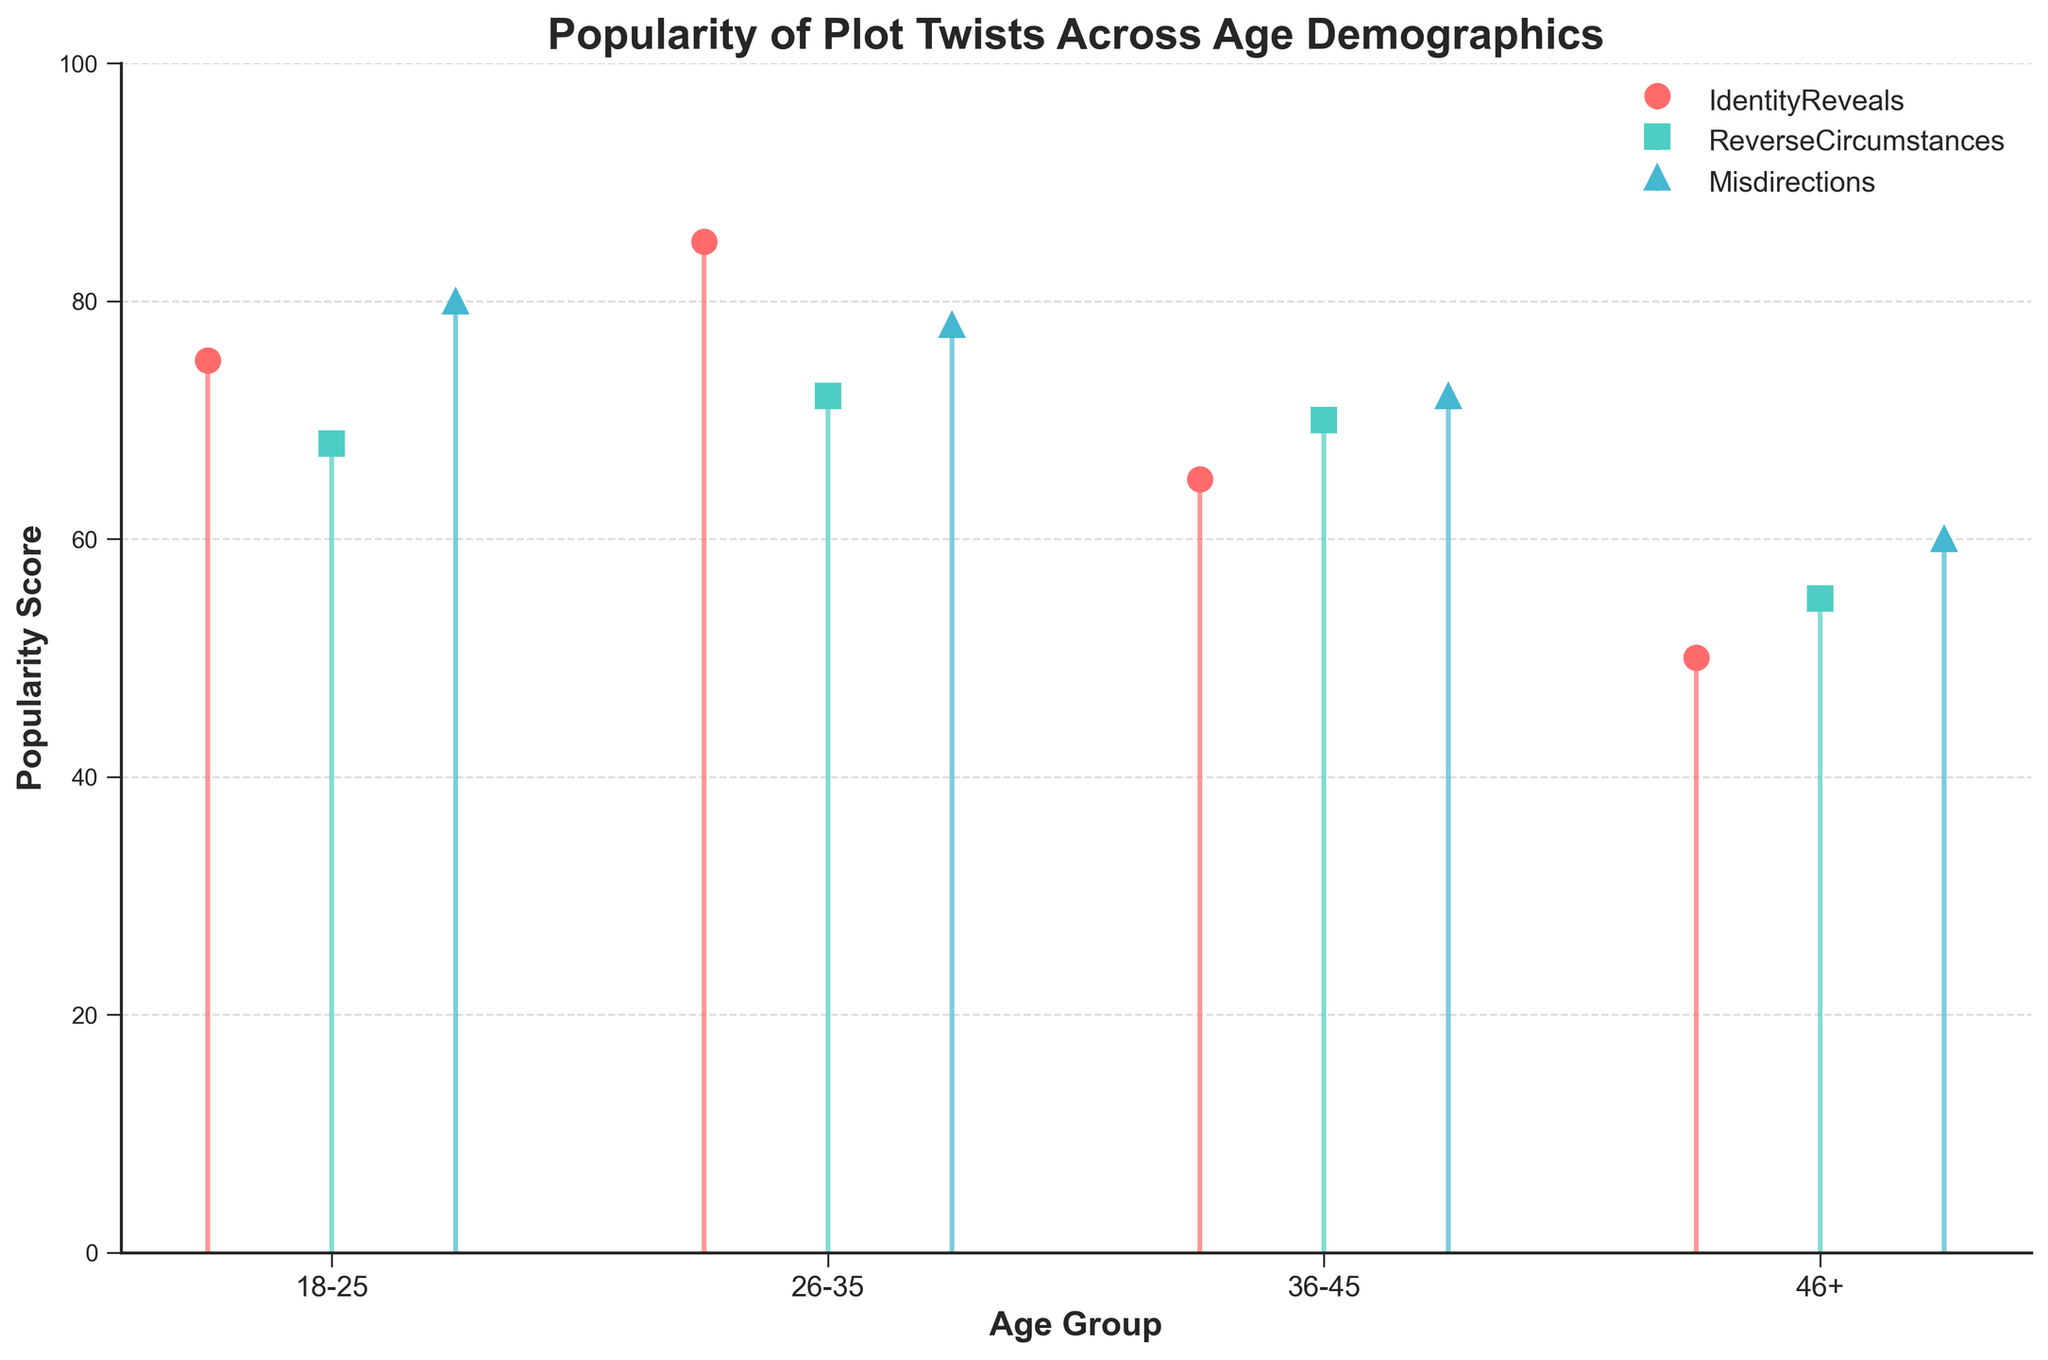What is the title of the figure? The title is displayed at the top of the figure. It reads 'Popularity of Plot Twists Across Age Demographics'.
Answer: Popularity of Plot Twists Across Age Demographics Which age group has the highest popularity score for 'Identity Reveals'? Look for the highest stem in the 'Identity Reveals' category. It's in the 26-35 age group.
Answer: 26-35 What is the difference between the popularity scores of 'Misdirections' for the age groups 18-25 and 46+? Find the scores for 'Misdirections' in 18-25 (80) and 46+ (60). Subtract 60 from 80.
Answer: 20 Which plot twist type is the least popular among the 46+ age group? Check the lowest stem in the 46+ age group. 'Identity Reveals' has the lowest score which is 50.
Answer: Identity Reveals How many plot twist types are shown in the figure? Count the different categories listed in the legend of the figure. There are three: Identity Reveals, Reverse Circumstances, and Misdirections.
Answer: 3 Which plot twist type has the most consistent popularity score across age groups? Check the variance in scores for each plot twist type across all age groups. 'Misdirections' ranges only from 60 to 80, showing the least variation.
Answer: Misdirections Between the ages 26-35 and 36-45, which age group shows a higher popularity score for 'Reverse Circumstances'? Compare the scores for 'Reverse Circumstances'. For 26-35, it's 72 while for 36-45 it's 70.
Answer: 26-35 What is the average popularity score of 'Identity Reveals' across all age groups? Add the scores for 'Identity Reveals': (75 + 85 + 65 + 50 = 275). Divide by the number of age groups, which is 4.
Answer: 68.75 Which age demographic shows the lowest overall interest in plot twists based on average scores? Calculate the average scores for each age group. 46+ has the lowest average, calculated as (50+55+60)/3 = 55.
Answer: 46+ How does the popularity score of 'Reverse Circumstances' change from the 18-25 to the 26-35 age group? The score changes from 68 to 72. Subtracting 68 from 72 gives the change.
Answer: Increase by 4 